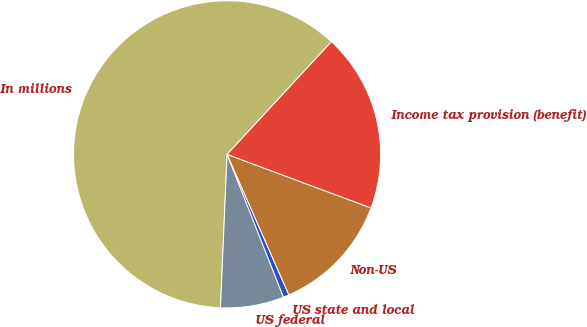Convert chart to OTSL. <chart><loc_0><loc_0><loc_500><loc_500><pie_chart><fcel>In millions<fcel>US federal<fcel>US state and local<fcel>Non-US<fcel>Income tax provision (benefit)<nl><fcel>61.2%<fcel>6.67%<fcel>0.61%<fcel>12.73%<fcel>18.79%<nl></chart> 